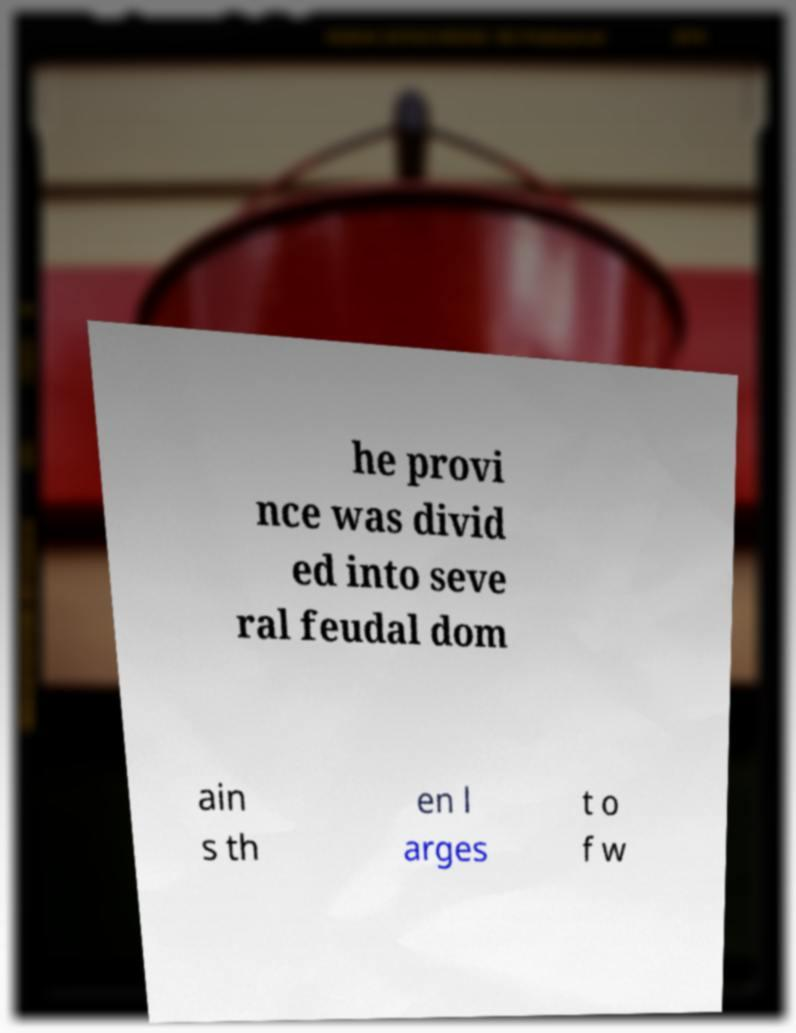Can you read and provide the text displayed in the image?This photo seems to have some interesting text. Can you extract and type it out for me? he provi nce was divid ed into seve ral feudal dom ain s th en l arges t o f w 